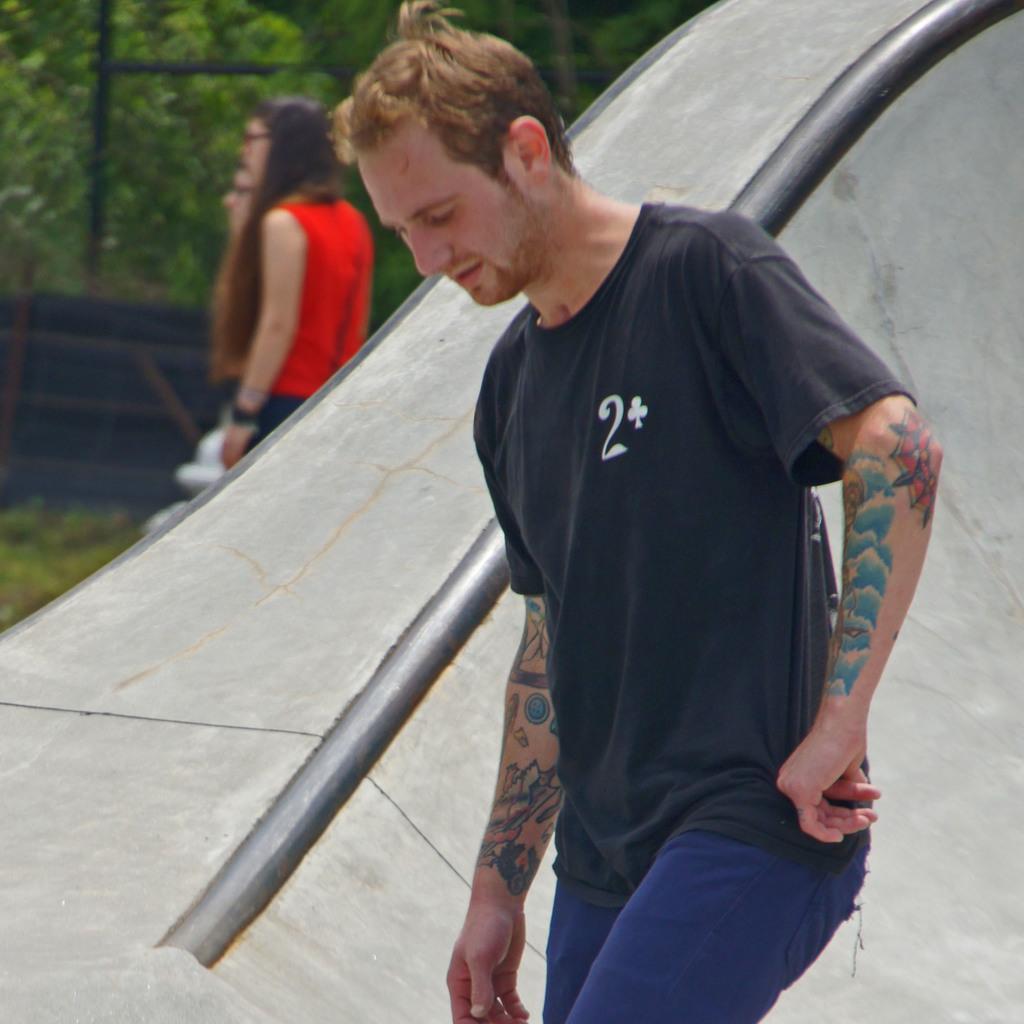Can you describe this image briefly? In this image at front there is a person. Behind him there is a wall. At the backside of the wall there are two other persons standing on the surface of the grass. At the background there are trees. 